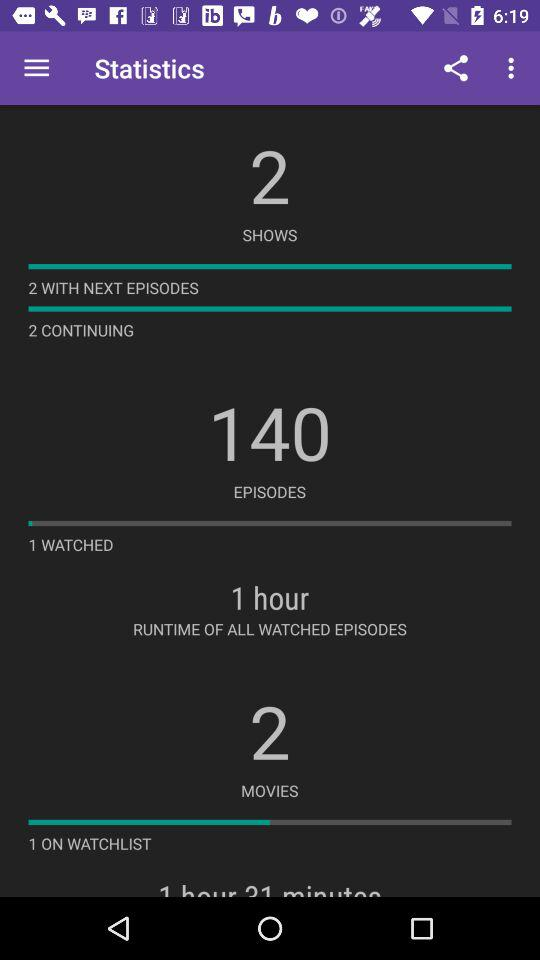What is the number of shows? The number of shows is 2. 